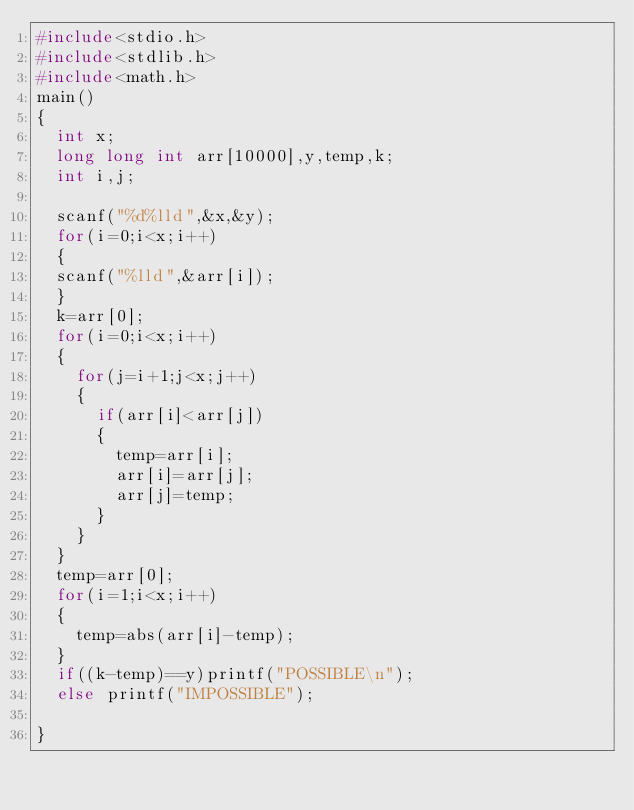Convert code to text. <code><loc_0><loc_0><loc_500><loc_500><_C_>#include<stdio.h>
#include<stdlib.h>
#include<math.h>
main()
{
	int x;
	long long int arr[10000],y,temp,k;
	int i,j;
	
	scanf("%d%lld",&x,&y);
	for(i=0;i<x;i++)
	{
	scanf("%lld",&arr[i]);
	}
	k=arr[0];
	for(i=0;i<x;i++)
	{
		for(j=i+1;j<x;j++)
		{
			if(arr[i]<arr[j])
			{
				temp=arr[i];
				arr[i]=arr[j];
				arr[j]=temp;
			}
		}
	}
	temp=arr[0];
	for(i=1;i<x;i++)
	{
		temp=abs(arr[i]-temp);
	}
	if((k-temp)==y)printf("POSSIBLE\n");
	else printf("IMPOSSIBLE");
	
}</code> 